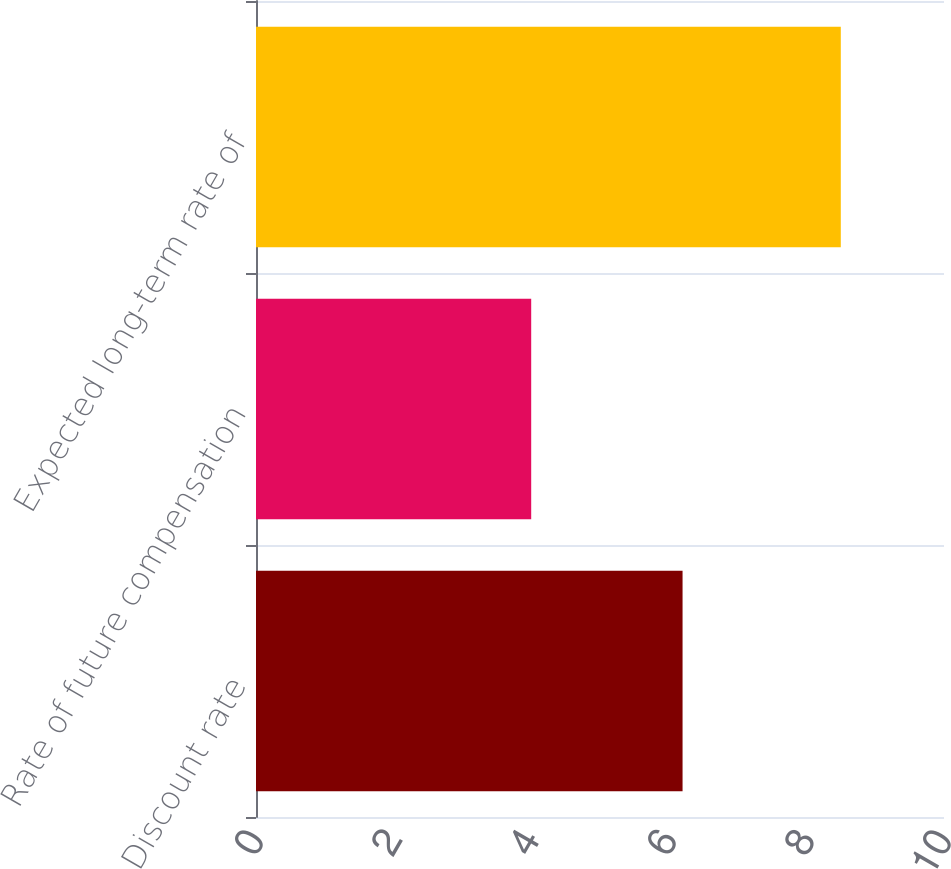Convert chart to OTSL. <chart><loc_0><loc_0><loc_500><loc_500><bar_chart><fcel>Discount rate<fcel>Rate of future compensation<fcel>Expected long-term rate of<nl><fcel>6.2<fcel>4<fcel>8.5<nl></chart> 